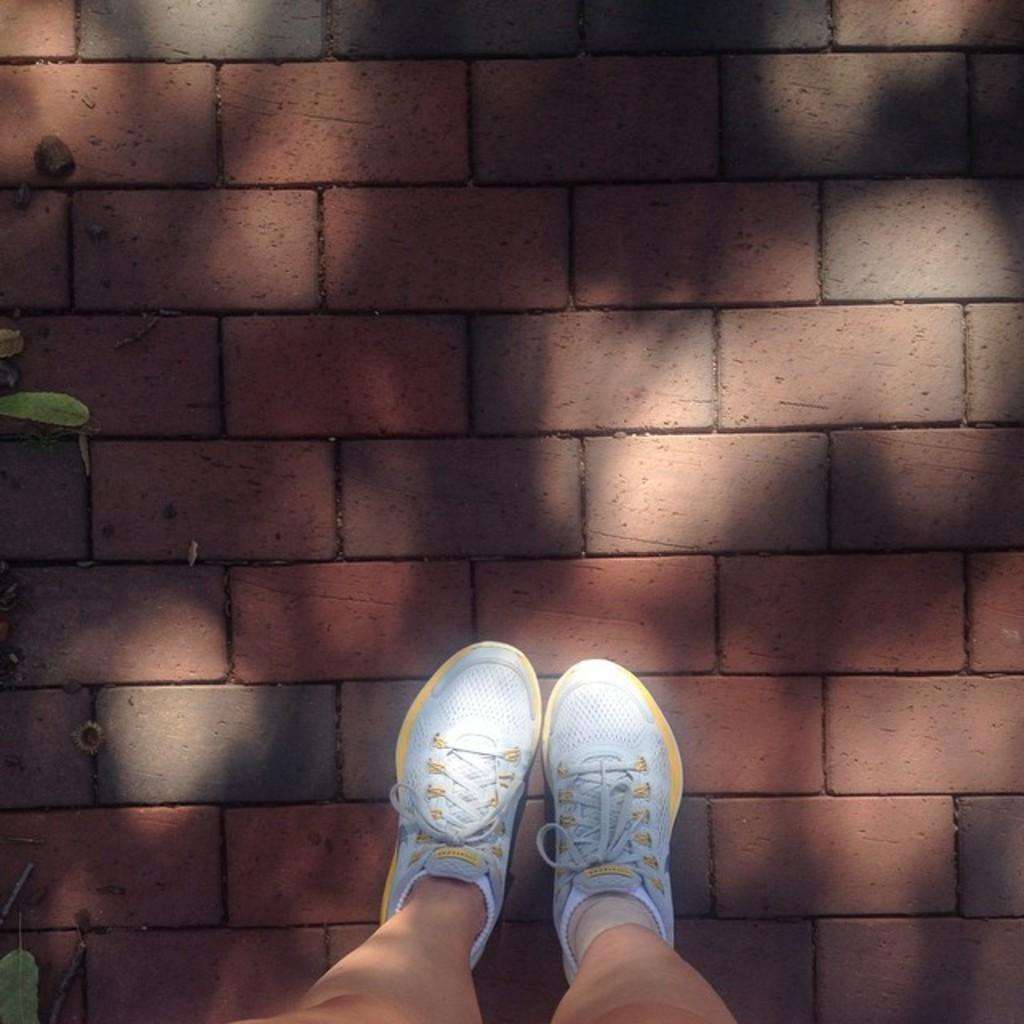What part of a person can be seen in the image? There are legs of a person in the image. What type of floor is visible in the image? There is a bricks floor in the image. What natural elements are present in the image? Leaves are present in the image. Can you determine the time of day the image was taken? The image was likely taken during the day, as there is sufficient light to see the details. What type of linen is draped over the person's legs in the image? There is no linen draped over the person's legs in the image; only their legs and the bricks floor are visible. 